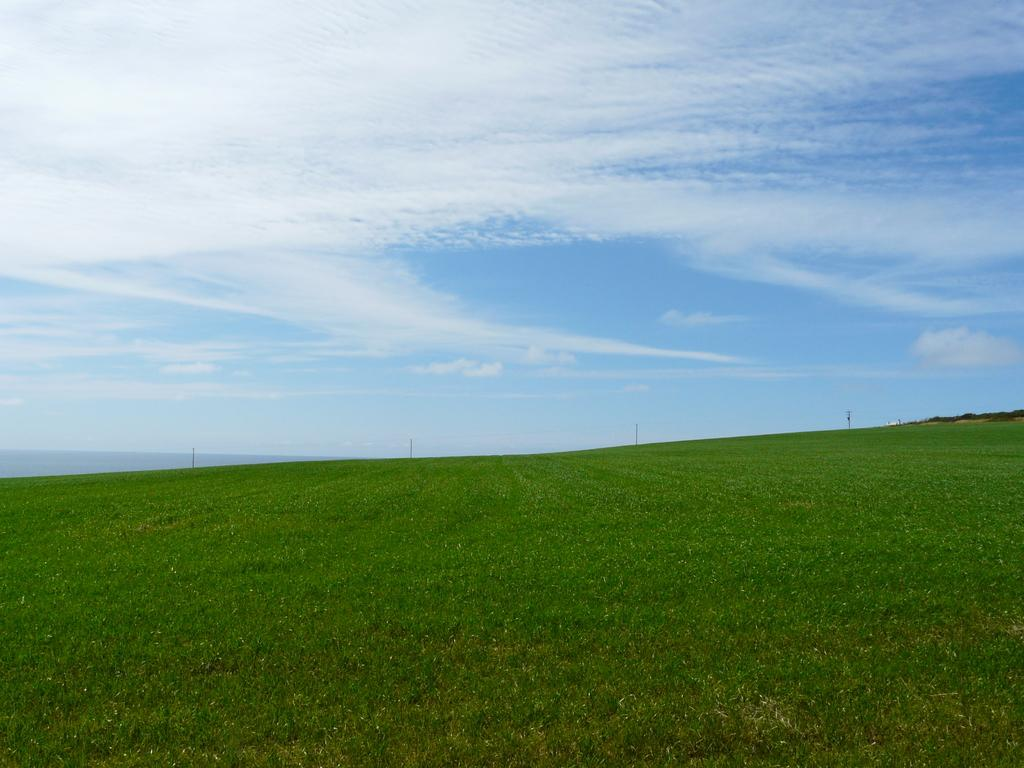What type of vegetation can be seen in the image? There is grass in the image. What structures are present in the image? There are poles in the image. What is visible in the background of the image? The sky is visible in the background of the image. What can be seen in the sky? Clouds are present in the sky. Can you tell me how many birds are standing on the quicksand in the image? There is no quicksand or bird present in the image. What is the comparison between the grass and the bird in the image? There is no bird in the image to make a comparison with the grass. 